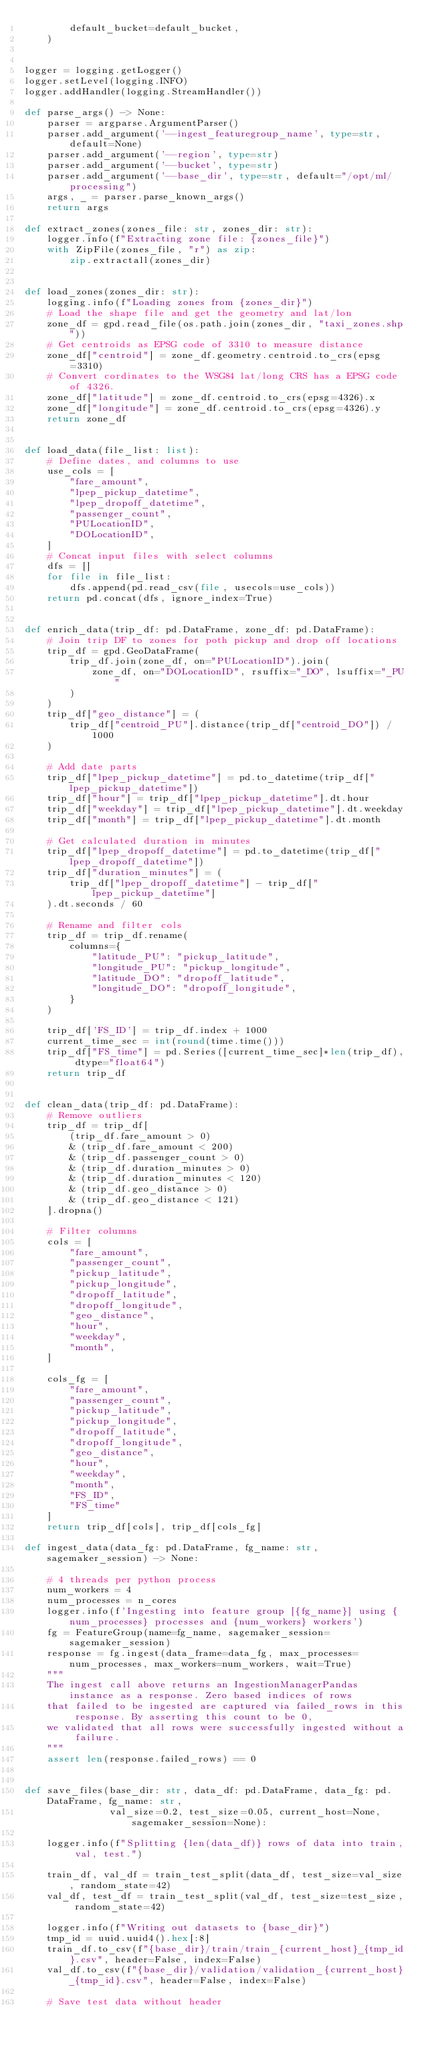<code> <loc_0><loc_0><loc_500><loc_500><_Python_>        default_bucket=default_bucket,
    )


logger = logging.getLogger()
logger.setLevel(logging.INFO)
logger.addHandler(logging.StreamHandler())

def parse_args() -> None:
    parser = argparse.ArgumentParser()
    parser.add_argument('--ingest_featuregroup_name', type=str, default=None)
    parser.add_argument('--region', type=str)
    parser.add_argument('--bucket', type=str)
    parser.add_argument('--base_dir', type=str, default="/opt/ml/processing")
    args, _ = parser.parse_known_args()
    return args

def extract_zones(zones_file: str, zones_dir: str):
    logger.info(f"Extracting zone file: {zones_file}")
    with ZipFile(zones_file, "r") as zip:
        zip.extractall(zones_dir)


def load_zones(zones_dir: str):
    logging.info(f"Loading zones from {zones_dir}")
    # Load the shape file and get the geometry and lat/lon
    zone_df = gpd.read_file(os.path.join(zones_dir, "taxi_zones.shp"))
    # Get centroids as EPSG code of 3310 to measure distance
    zone_df["centroid"] = zone_df.geometry.centroid.to_crs(epsg=3310)
    # Convert cordinates to the WSG84 lat/long CRS has a EPSG code of 4326.
    zone_df["latitude"] = zone_df.centroid.to_crs(epsg=4326).x
    zone_df["longitude"] = zone_df.centroid.to_crs(epsg=4326).y
    return zone_df


def load_data(file_list: list):
    # Define dates, and columns to use
    use_cols = [
        "fare_amount",
        "lpep_pickup_datetime",
        "lpep_dropoff_datetime",
        "passenger_count",
        "PULocationID",
        "DOLocationID",
    ]
    # Concat input files with select columns
    dfs = []
    for file in file_list:
        dfs.append(pd.read_csv(file, usecols=use_cols))
    return pd.concat(dfs, ignore_index=True)


def enrich_data(trip_df: pd.DataFrame, zone_df: pd.DataFrame):
    # Join trip DF to zones for poth pickup and drop off locations
    trip_df = gpd.GeoDataFrame(
        trip_df.join(zone_df, on="PULocationID").join(
            zone_df, on="DOLocationID", rsuffix="_DO", lsuffix="_PU"
        )
    )
    trip_df["geo_distance"] = (
        trip_df["centroid_PU"].distance(trip_df["centroid_DO"]) / 1000
    )

    # Add date parts
    trip_df["lpep_pickup_datetime"] = pd.to_datetime(trip_df["lpep_pickup_datetime"])
    trip_df["hour"] = trip_df["lpep_pickup_datetime"].dt.hour
    trip_df["weekday"] = trip_df["lpep_pickup_datetime"].dt.weekday
    trip_df["month"] = trip_df["lpep_pickup_datetime"].dt.month

    # Get calculated duration in minutes
    trip_df["lpep_dropoff_datetime"] = pd.to_datetime(trip_df["lpep_dropoff_datetime"])
    trip_df["duration_minutes"] = (
        trip_df["lpep_dropoff_datetime"] - trip_df["lpep_pickup_datetime"]
    ).dt.seconds / 60

    # Rename and filter cols
    trip_df = trip_df.rename(
        columns={
            "latitude_PU": "pickup_latitude",
            "longitude_PU": "pickup_longitude",
            "latitude_DO": "dropoff_latitude",
            "longitude_DO": "dropoff_longitude",
        }
    )
    
    trip_df['FS_ID'] = trip_df.index + 1000
    current_time_sec = int(round(time.time()))
    trip_df["FS_time"] = pd.Series([current_time_sec]*len(trip_df), dtype="float64")
    return trip_df


def clean_data(trip_df: pd.DataFrame):
    # Remove outliers
    trip_df = trip_df[
        (trip_df.fare_amount > 0)
        & (trip_df.fare_amount < 200)
        & (trip_df.passenger_count > 0)
        & (trip_df.duration_minutes > 0)
        & (trip_df.duration_minutes < 120)
        & (trip_df.geo_distance > 0)
        & (trip_df.geo_distance < 121)
    ].dropna()

    # Filter columns
    cols = [
        "fare_amount",
        "passenger_count",
        "pickup_latitude",
        "pickup_longitude",
        "dropoff_latitude",
        "dropoff_longitude",
        "geo_distance",
        "hour",
        "weekday",
        "month",
    ]
    
    cols_fg = [
        "fare_amount",
        "passenger_count",
        "pickup_latitude",
        "pickup_longitude",
        "dropoff_latitude",
        "dropoff_longitude",
        "geo_distance",
        "hour",
        "weekday",
        "month",
        "FS_ID",
        "FS_time"
    ]
    return trip_df[cols], trip_df[cols_fg]

def ingest_data(data_fg: pd.DataFrame, fg_name: str, sagemaker_session) -> None:
    
    # 4 threads per python process
    num_workers = 4
    num_processes = n_cores
    logger.info(f'Ingesting into feature group [{fg_name}] using {num_processes} processes and {num_workers} workers')
    fg = FeatureGroup(name=fg_name, sagemaker_session=sagemaker_session)
    response = fg.ingest(data_frame=data_fg, max_processes=num_processes, max_workers=num_workers, wait=True)
    """
    The ingest call above returns an IngestionManagerPandas instance as a response. Zero based indices of rows 
    that failed to be ingested are captured via failed_rows in this response. By asserting this count to be 0,
    we validated that all rows were successfully ingested without a failure.
    """
    assert len(response.failed_rows) == 0


def save_files(base_dir: str, data_df: pd.DataFrame, data_fg: pd.DataFrame, fg_name: str, 
               val_size=0.2, test_size=0.05, current_host=None, sagemaker_session=None):
        
    logger.info(f"Splitting {len(data_df)} rows of data into train, val, test.")

    train_df, val_df = train_test_split(data_df, test_size=val_size, random_state=42)
    val_df, test_df = train_test_split(val_df, test_size=test_size, random_state=42)

    logger.info(f"Writing out datasets to {base_dir}")
    tmp_id = uuid.uuid4().hex[:8]
    train_df.to_csv(f"{base_dir}/train/train_{current_host}_{tmp_id}.csv", header=False, index=False)
    val_df.to_csv(f"{base_dir}/validation/validation_{current_host}_{tmp_id}.csv", header=False, index=False)

    # Save test data without header</code> 